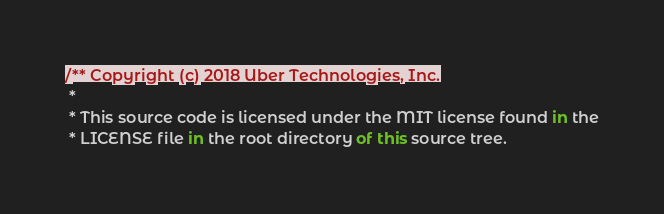Convert code to text. <code><loc_0><loc_0><loc_500><loc_500><_JavaScript_>/** Copyright (c) 2018 Uber Technologies, Inc.
 *
 * This source code is licensed under the MIT license found in the
 * LICENSE file in the root directory of this source tree.</code> 